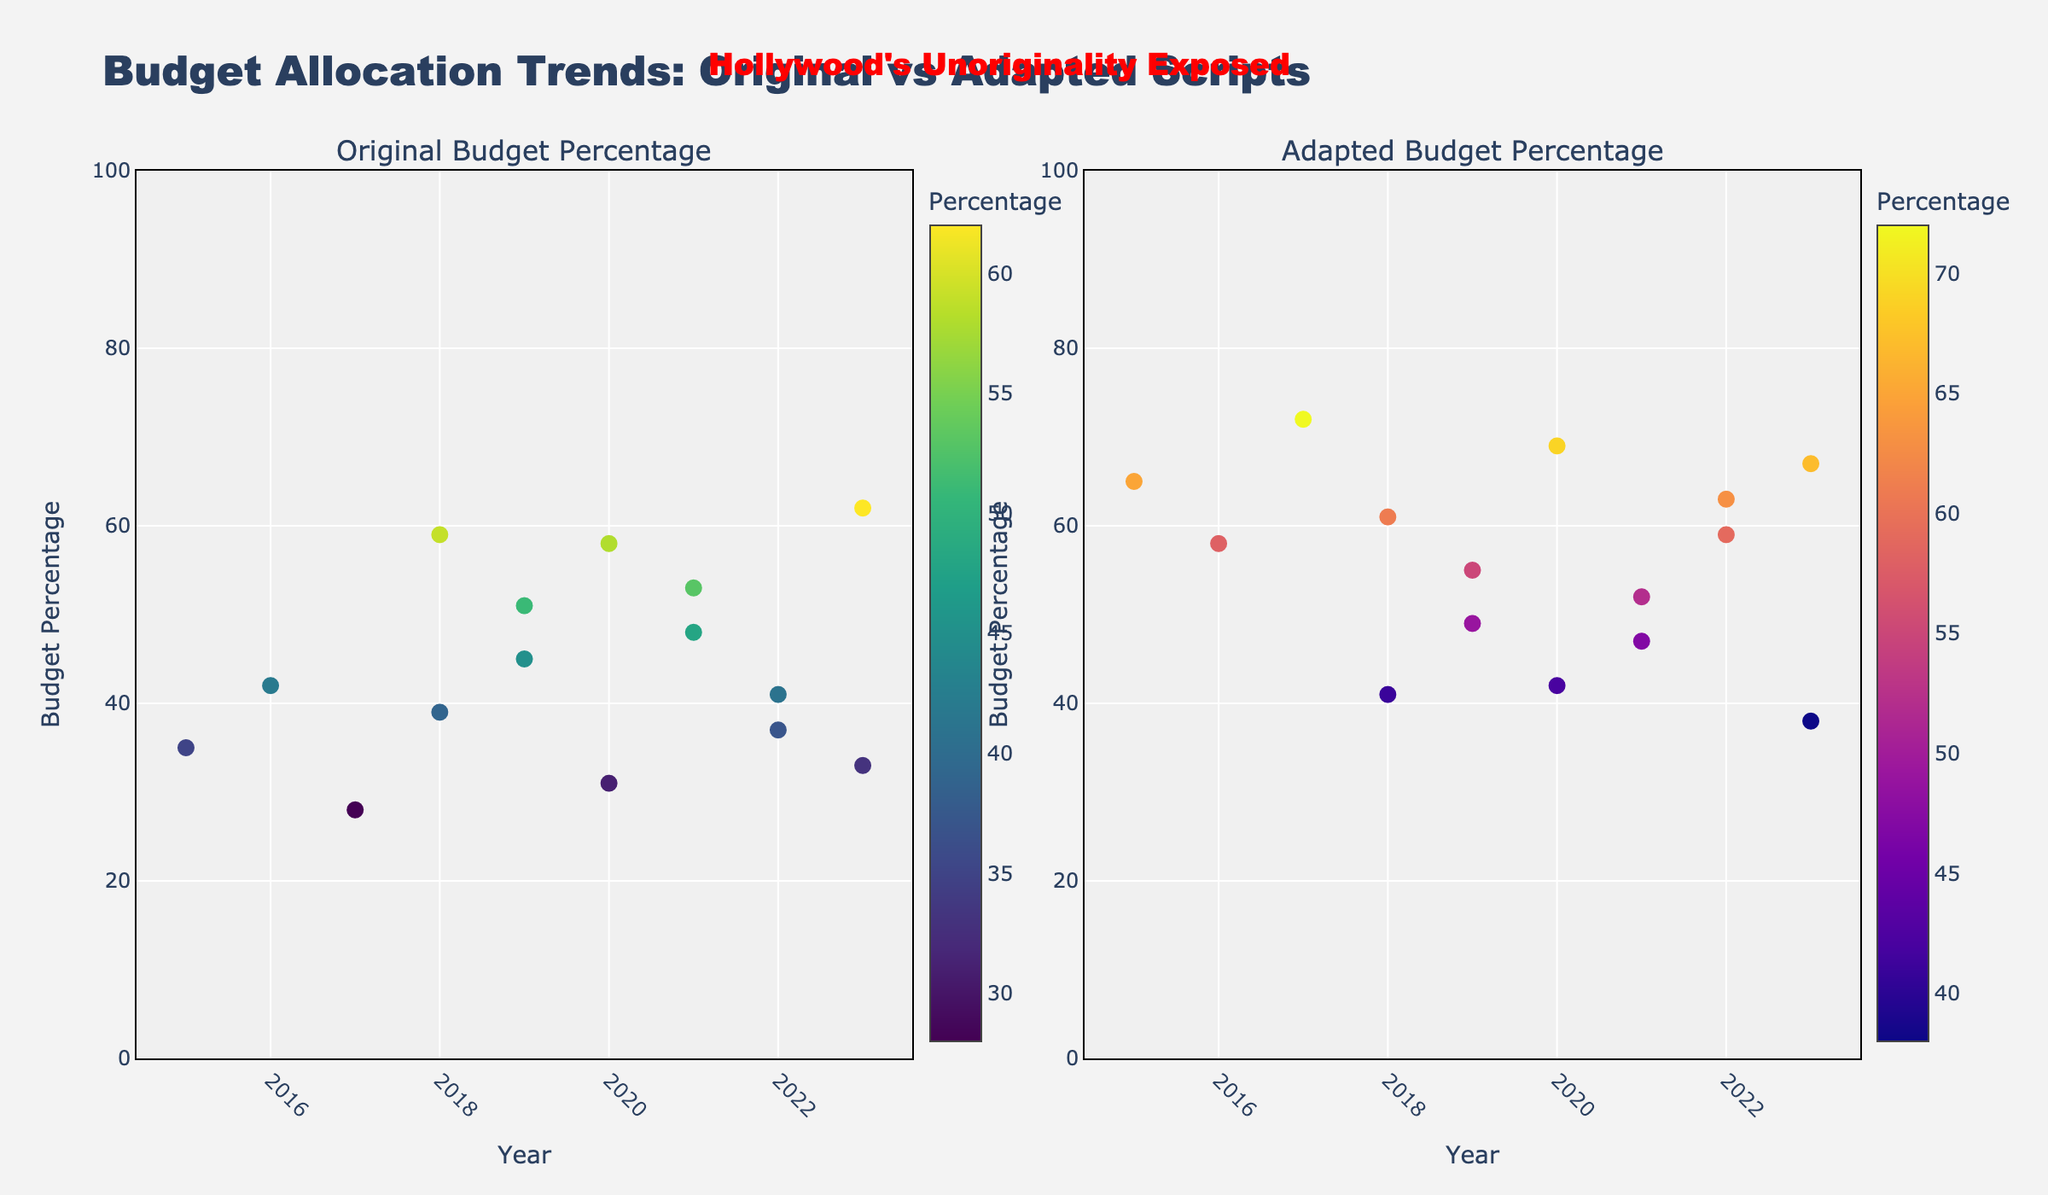what is the title of the figure? The title is displayed at the top of the figure and reads "Budget Allocation Trends: Original vs Adapted Scripts".
Answer: Budget Allocation Trends: Original vs Adapted Scripts Which studio had the highest percentage of budget allocated to original screenplays? Locate the highest point on the left scatter plot of "Original Budget Percentage". A24 in 2023 has the highest original budget percentage at 62%.
Answer: A24 Which studio had the lowest percentage of budget allocated to adapted scripts in 2023? Look at the right scatter plot under the year 2023 and identify the lowest point. A24 in 2023 had the lowest adapted budget percentage of 38%.
Answer: A24 How does the budget percentage for original screenplays in 2018 compare between Universal and Annapurna Pictures? Observe both data points for 2018 in the left scatter plot. Universal allocated 39% while Annapurna Pictures allocated 59%. Calculate their difference, 59% - 39% = 20%.
Answer: Annapurna Pictures allocated 20% more Which studios are clustered around a 50% budget allocation for both original and adapted scripts? Identify the data points near the 50% mark on both scatter plots. Focus Features in 2021 (Original: 53%, Adapted: 47%) and STX Entertainment in 2019 (Original: 51%, Adapted: 49%) are near the 50% mark.
Answer: Focus Features, STX Entertainment Between 2015 and 2023, which year had the most significant difference in budget allocation between original and adapted scripts? Calculate the difference for each year from both scatter plots. In 2017, Disney shows the largest gap of 72% adapted and 28% original, giving a difference of 72% - 28% = 44%.
Answer: 2017 What is the average percentage of budget allocated to original scripts across all studios in 2020? Locate all points for 2020 under Original Budget. Warner Bros. (31%), Blumhouse (58%), calculate the average. Sum: 31 + 58 = 89, average: 89 / 2 = 44.5%.
Answer: 44.5% How many studios have more than 50% of their budget allocated to original screenplays? Count the points that are above 50% on the left scatter plot. Lionsgate, A24, Blumhouse, Focus Features, and Annapurna Pictures.
Answer: 5 